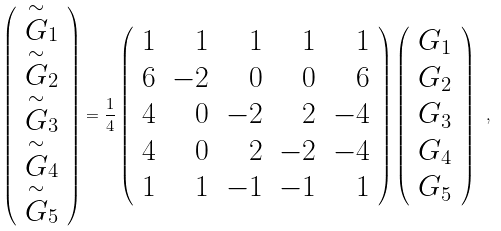<formula> <loc_0><loc_0><loc_500><loc_500>\left ( \begin{array} { c } { \stackrel { \sim } { G } } _ { 1 } \\ { \stackrel { \sim } { G } } _ { 2 } \\ { \stackrel { \sim } { G } } _ { 3 } \\ { \stackrel { \sim } { G } } _ { 4 } \\ { \stackrel { \sim } { G } } _ { 5 } \end{array} \right ) = \frac { 1 } { 4 } \left ( \begin{array} { r r r r r } 1 & 1 & 1 & 1 & 1 \\ 6 & - 2 & 0 & 0 & 6 \\ 4 & 0 & - 2 & 2 & - 4 \\ 4 & 0 & 2 & - 2 & - 4 \\ 1 & 1 & - 1 & - 1 & 1 \end{array} \right ) \left ( \begin{array} { c } G _ { 1 } \\ G _ { 2 } \\ G _ { 3 } \\ G _ { 4 } \\ G _ { 5 } \end{array} \right ) \ ,</formula> 